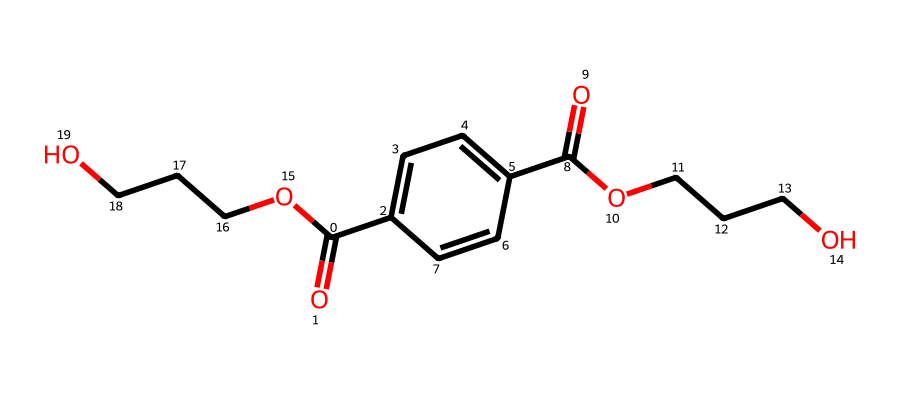How many carbon atoms are in this structure? The SMILES representation indicates a total of 10 carbon atoms present in both the aromatic ring and the aliphatic chains. Counting each 'C' in the SMILES gives the exact number.
Answer: 10 What type of functional groups are present? The chemical structure has carboxylic acid (-COOH) and ester (RCOOR') functional groups, identifiable in the connecting groups within the polymer backbone, such as the carboxyl end and the ether links.
Answer: carboxylic acid, ester What is the degree of polymerization for this monomer? For this particular SMILES representation, it represents a monomer structure of two repeating units, which indicates a degree of polymerization of 2.
Answer: 2 Is this polymer hydrophilic or hydrophobic? The presence of multiple ether and carboxylic acid groups in the structure suggests that it has some hydrophilic characteristics due to its ability to attract water molecules.
Answer: hydrophilic What type of plastic is represented by this structure? The structure from the SMILES indicates polyethylene terephthalate, commonly known as PET, which is a thermoplastic polymer widely used in making chips and bottles.
Answer: PET 